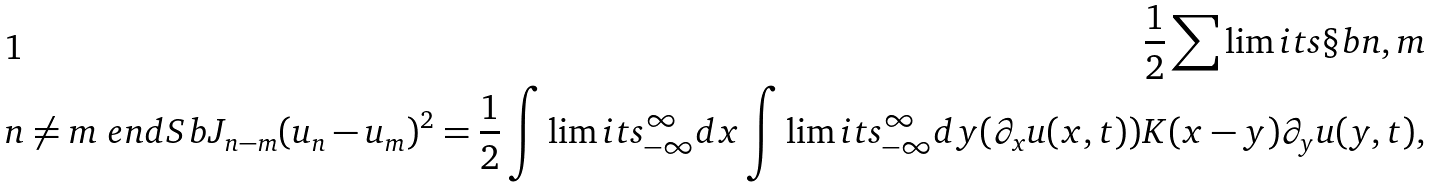<formula> <loc_0><loc_0><loc_500><loc_500>\frac { 1 } { 2 } \sum \lim i t s \S b n , m \\ n \neq m \ e n d S b J _ { n - m } ( u _ { n } - u _ { m } ) ^ { 2 } = \frac { 1 } { 2 } \int \lim i t s _ { - \infty } ^ { \infty } d x \int \lim i t s _ { - \infty } ^ { \infty } d y ( \partial _ { x } u ( x , t ) ) K ( x - y ) \partial _ { y } u ( y , t ) ,</formula> 